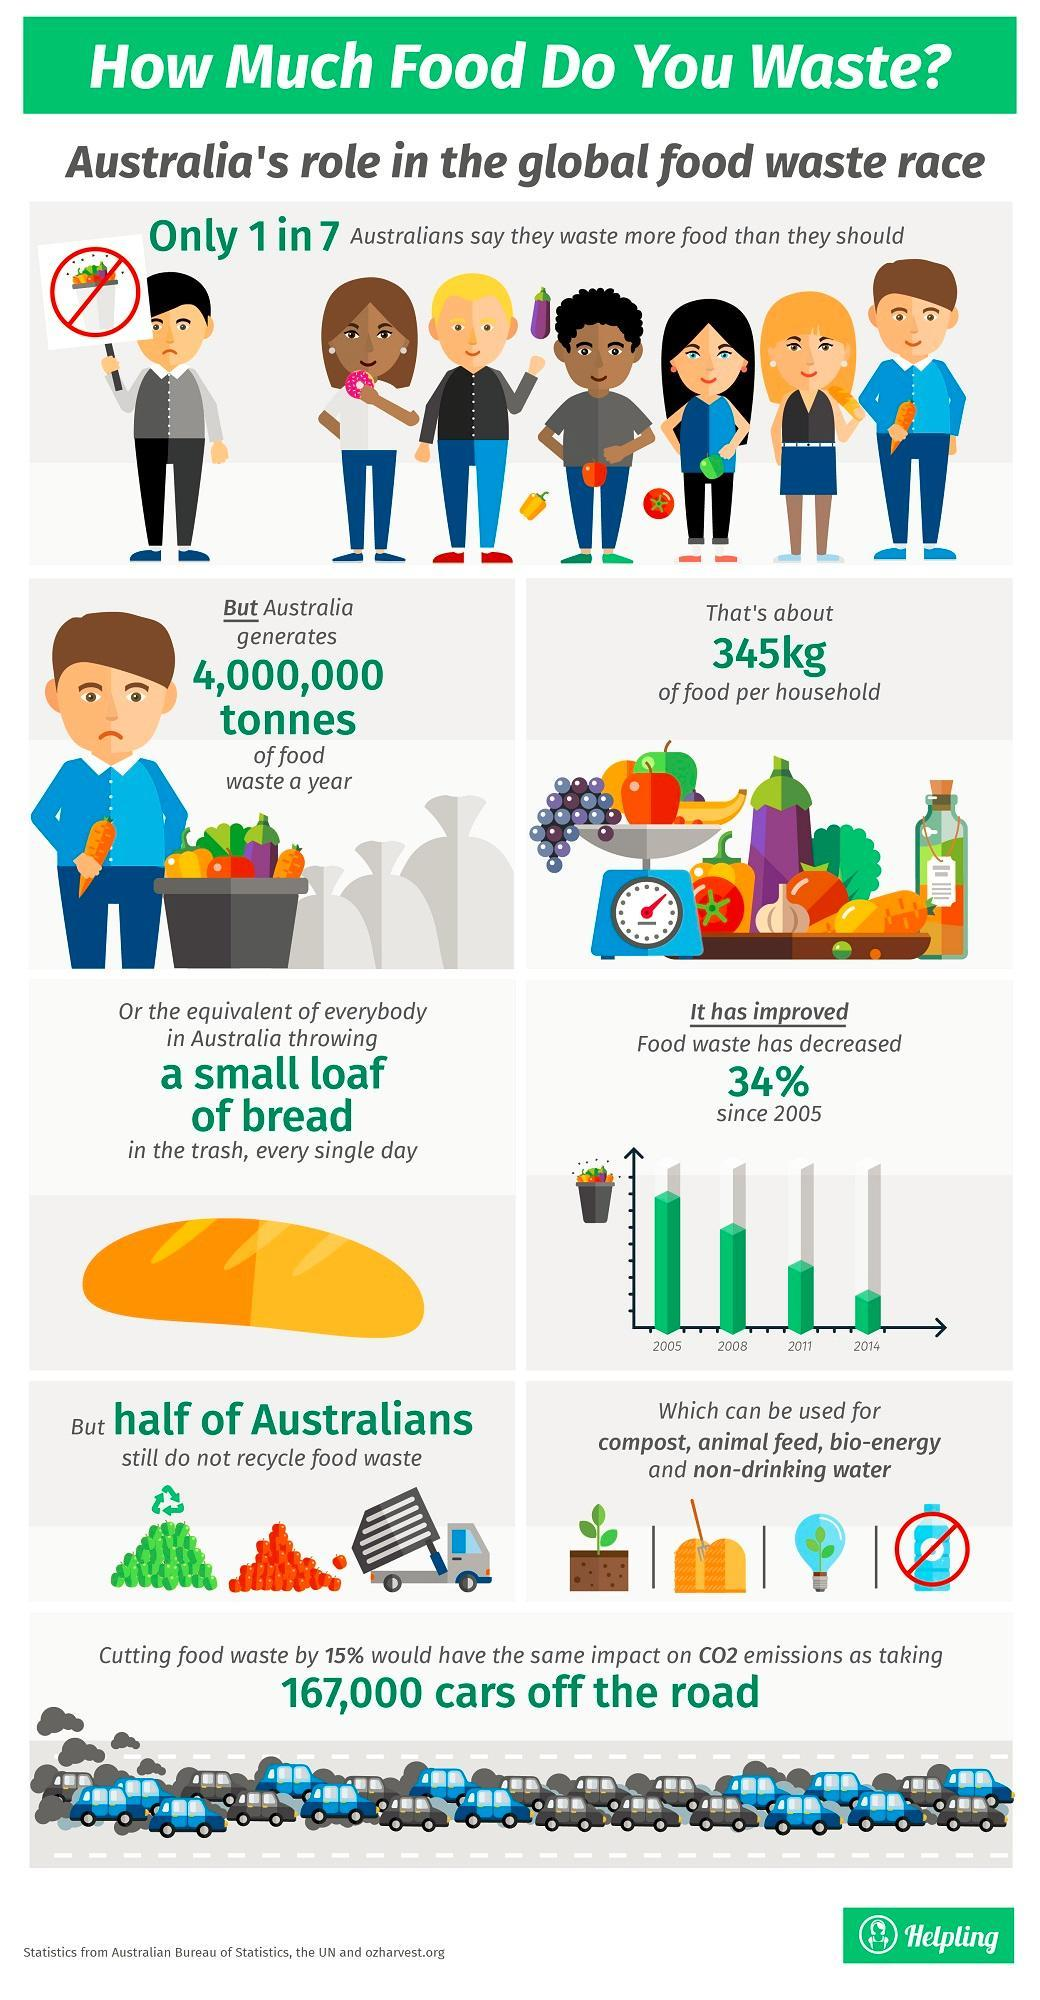Which of the following cannot be used while recycling food waste compost, animal feed, bio-energy or non-drinking water?
Answer the question with a short phrase. non-drinking water Which year shows the lowest reduction in food waste 2005, 2008, 2011, or 2014? 2014 